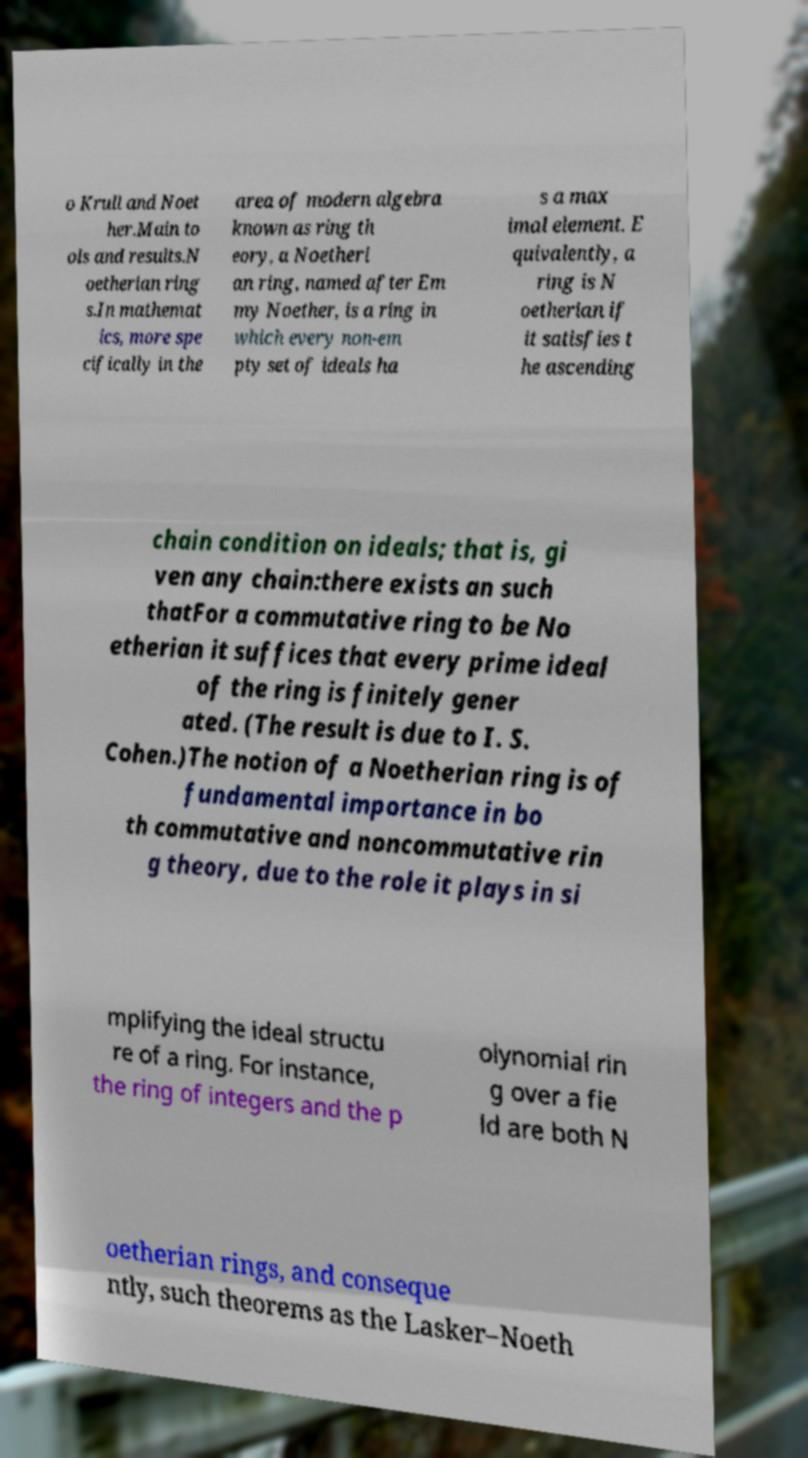What messages or text are displayed in this image? I need them in a readable, typed format. o Krull and Noet her.Main to ols and results.N oetherian ring s.In mathemat ics, more spe cifically in the area of modern algebra known as ring th eory, a Noetheri an ring, named after Em my Noether, is a ring in which every non-em pty set of ideals ha s a max imal element. E quivalently, a ring is N oetherian if it satisfies t he ascending chain condition on ideals; that is, gi ven any chain:there exists an such thatFor a commutative ring to be No etherian it suffices that every prime ideal of the ring is finitely gener ated. (The result is due to I. S. Cohen.)The notion of a Noetherian ring is of fundamental importance in bo th commutative and noncommutative rin g theory, due to the role it plays in si mplifying the ideal structu re of a ring. For instance, the ring of integers and the p olynomial rin g over a fie ld are both N oetherian rings, and conseque ntly, such theorems as the Lasker–Noeth 